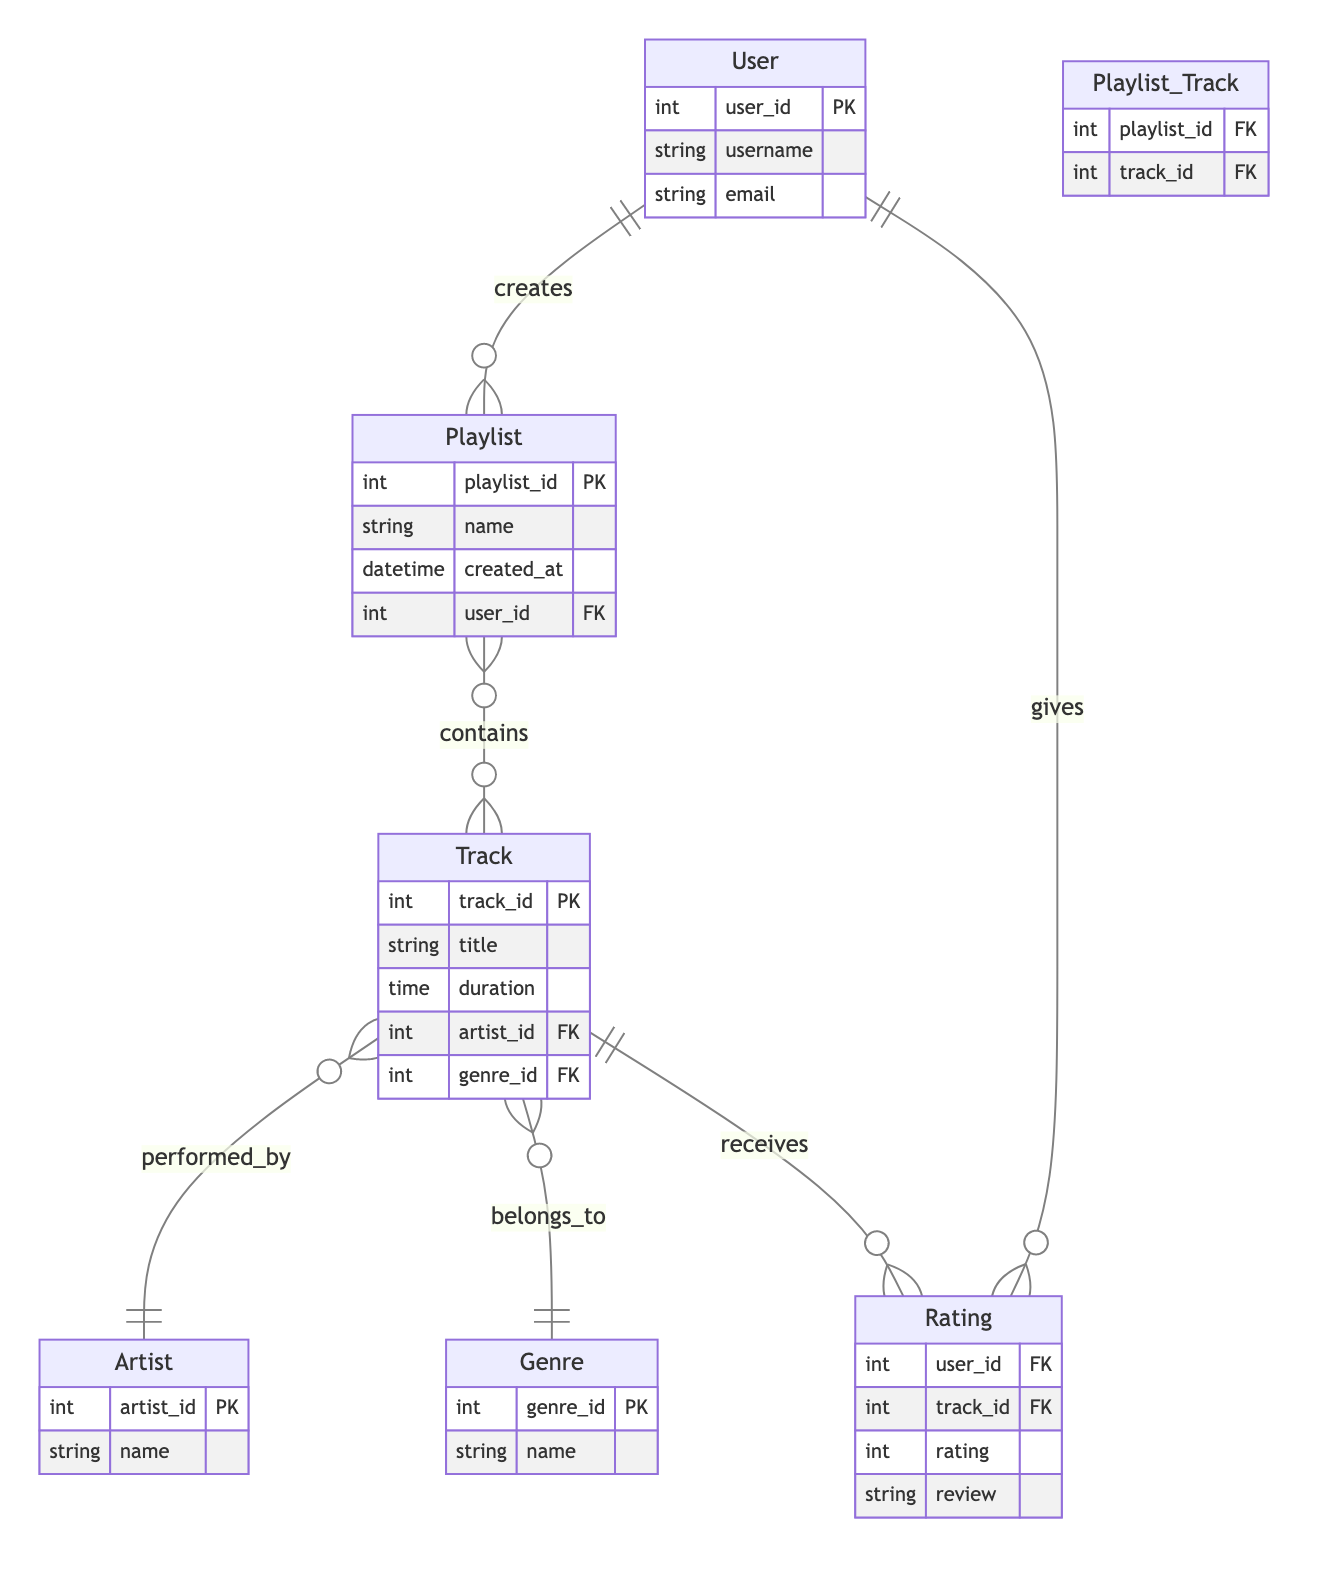What is the primary key of the User entity? The primary key attribute is specified as "user_id," which uniquely identifies each user in the User entity.
Answer: user_id How many attributes does the Track entity have? The Track entity contains four attributes: track_id, title, duration, artist_id, and genre_id, which sums up to five in total.
Answer: five What relationship type exists between Playlist and Track? The relationship is indicated as "N:M," meaning many playlists can contain many tracks, and this is represented with a join table (Playlist_Track).
Answer: N:M Which entity is connected to the Track entity via the artist_id foreign key? The relationship shows that the Track entity performs a connection to the Artist entity, indicating that each track is associated with a specific artist through the artist_id foreign key.
Answer: Artist How many relationships involve the User entity? The User entity is involved in three relationships: "User_Playlist," "User_Rating," and it also connects indirectly through the Rating relationship, which results in three relationships in total.
Answer: three What is the foreign key in the Playlist entity? The foreign key in the Playlist entity is identified as "user_id," establishing a connection to the User entity.
Answer: user_id What can be inferred from the Rating entity? The Rating entity captures information about user ratings for tracks including user_id, track_id, rating, and review, indicating a direct relationship with both User and Track entities for feedback.
Answer: feedback Which entity can have multiple ratings according to the diagram? The Track entity can have multiple ratings associated with it because of the one-to-many relationship shown between Track and Rating, denoting that each track can receive multiple user ratings.
Answer: Track Which entities have a one-to-many relationship with the Track entity? The Track entity has a one-to-many relationship with two entities: Artist (through artist_id) and Genre (through genre_id), meaning each track is performed by one artist and belongs to one genre.
Answer: Artist and Genre 